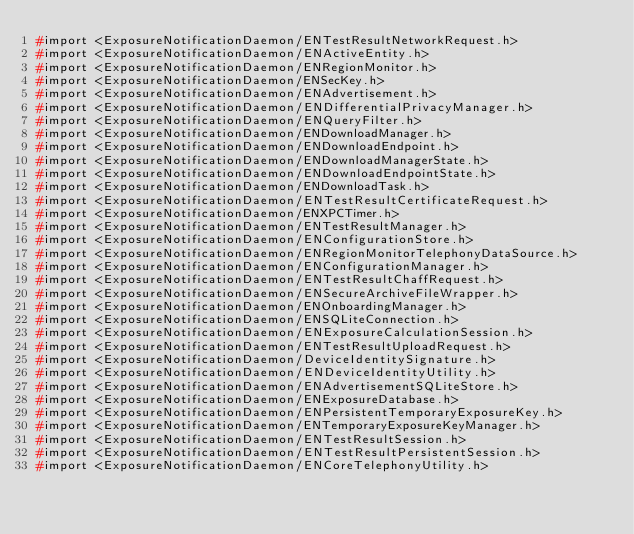<code> <loc_0><loc_0><loc_500><loc_500><_C_>#import <ExposureNotificationDaemon/ENTestResultNetworkRequest.h>
#import <ExposureNotificationDaemon/ENActiveEntity.h>
#import <ExposureNotificationDaemon/ENRegionMonitor.h>
#import <ExposureNotificationDaemon/ENSecKey.h>
#import <ExposureNotificationDaemon/ENAdvertisement.h>
#import <ExposureNotificationDaemon/ENDifferentialPrivacyManager.h>
#import <ExposureNotificationDaemon/ENQueryFilter.h>
#import <ExposureNotificationDaemon/ENDownloadManager.h>
#import <ExposureNotificationDaemon/ENDownloadEndpoint.h>
#import <ExposureNotificationDaemon/ENDownloadManagerState.h>
#import <ExposureNotificationDaemon/ENDownloadEndpointState.h>
#import <ExposureNotificationDaemon/ENDownloadTask.h>
#import <ExposureNotificationDaemon/ENTestResultCertificateRequest.h>
#import <ExposureNotificationDaemon/ENXPCTimer.h>
#import <ExposureNotificationDaemon/ENTestResultManager.h>
#import <ExposureNotificationDaemon/ENConfigurationStore.h>
#import <ExposureNotificationDaemon/ENRegionMonitorTelephonyDataSource.h>
#import <ExposureNotificationDaemon/ENConfigurationManager.h>
#import <ExposureNotificationDaemon/ENTestResultChaffRequest.h>
#import <ExposureNotificationDaemon/ENSecureArchiveFileWrapper.h>
#import <ExposureNotificationDaemon/ENOnboardingManager.h>
#import <ExposureNotificationDaemon/ENSQLiteConnection.h>
#import <ExposureNotificationDaemon/ENExposureCalculationSession.h>
#import <ExposureNotificationDaemon/ENTestResultUploadRequest.h>
#import <ExposureNotificationDaemon/DeviceIdentitySignature.h>
#import <ExposureNotificationDaemon/ENDeviceIdentityUtility.h>
#import <ExposureNotificationDaemon/ENAdvertisementSQLiteStore.h>
#import <ExposureNotificationDaemon/ENExposureDatabase.h>
#import <ExposureNotificationDaemon/ENPersistentTemporaryExposureKey.h>
#import <ExposureNotificationDaemon/ENTemporaryExposureKeyManager.h>
#import <ExposureNotificationDaemon/ENTestResultSession.h>
#import <ExposureNotificationDaemon/ENTestResultPersistentSession.h>
#import <ExposureNotificationDaemon/ENCoreTelephonyUtility.h></code> 